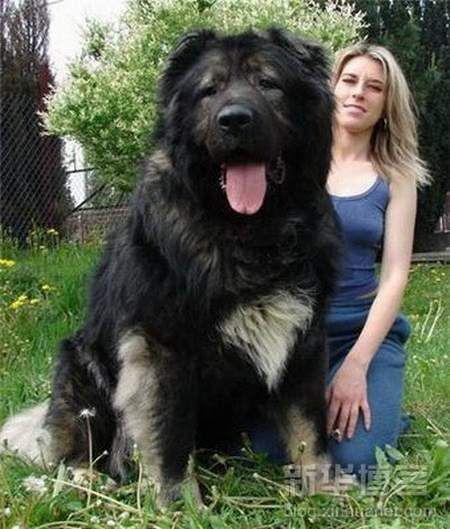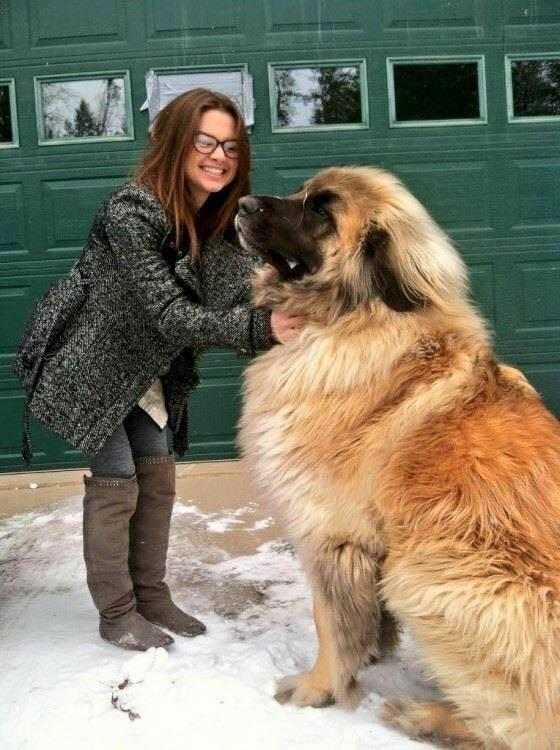The first image is the image on the left, the second image is the image on the right. Analyze the images presented: Is the assertion "In one image, a kneeling woman's head is nearly even with that of the large dog she poses next to." valid? Answer yes or no. Yes. The first image is the image on the left, the second image is the image on the right. Assess this claim about the two images: "The left image includes a human interacting with a large dog.". Correct or not? Answer yes or no. Yes. 